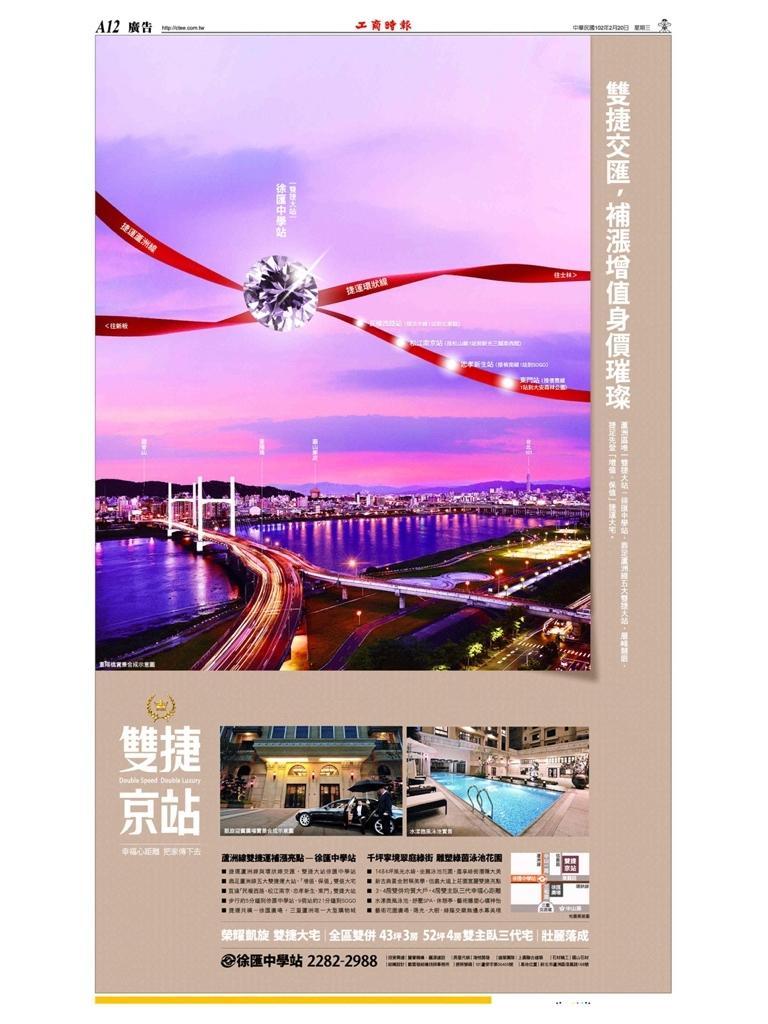How would you summarize this image in a sentence or two? There is a poster, in which, there are three images. In first image, there is bridge, which is built across the river, there are buildings and there are clouds in the sky. In the second image, there is a car on the road, near a building. In the third image, there is a swimming pool, around this swimming pool, there are beds arranged. Outside these images, there are texts. 